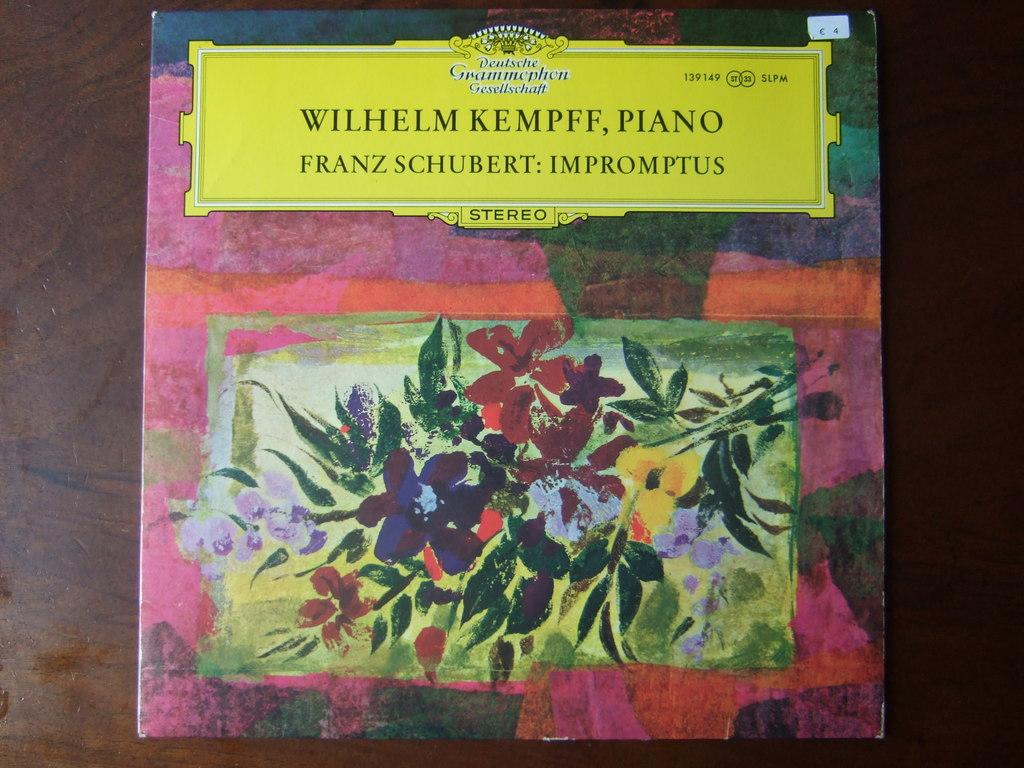<image>
Relay a brief, clear account of the picture shown. a book with the name wilhelm at the top 